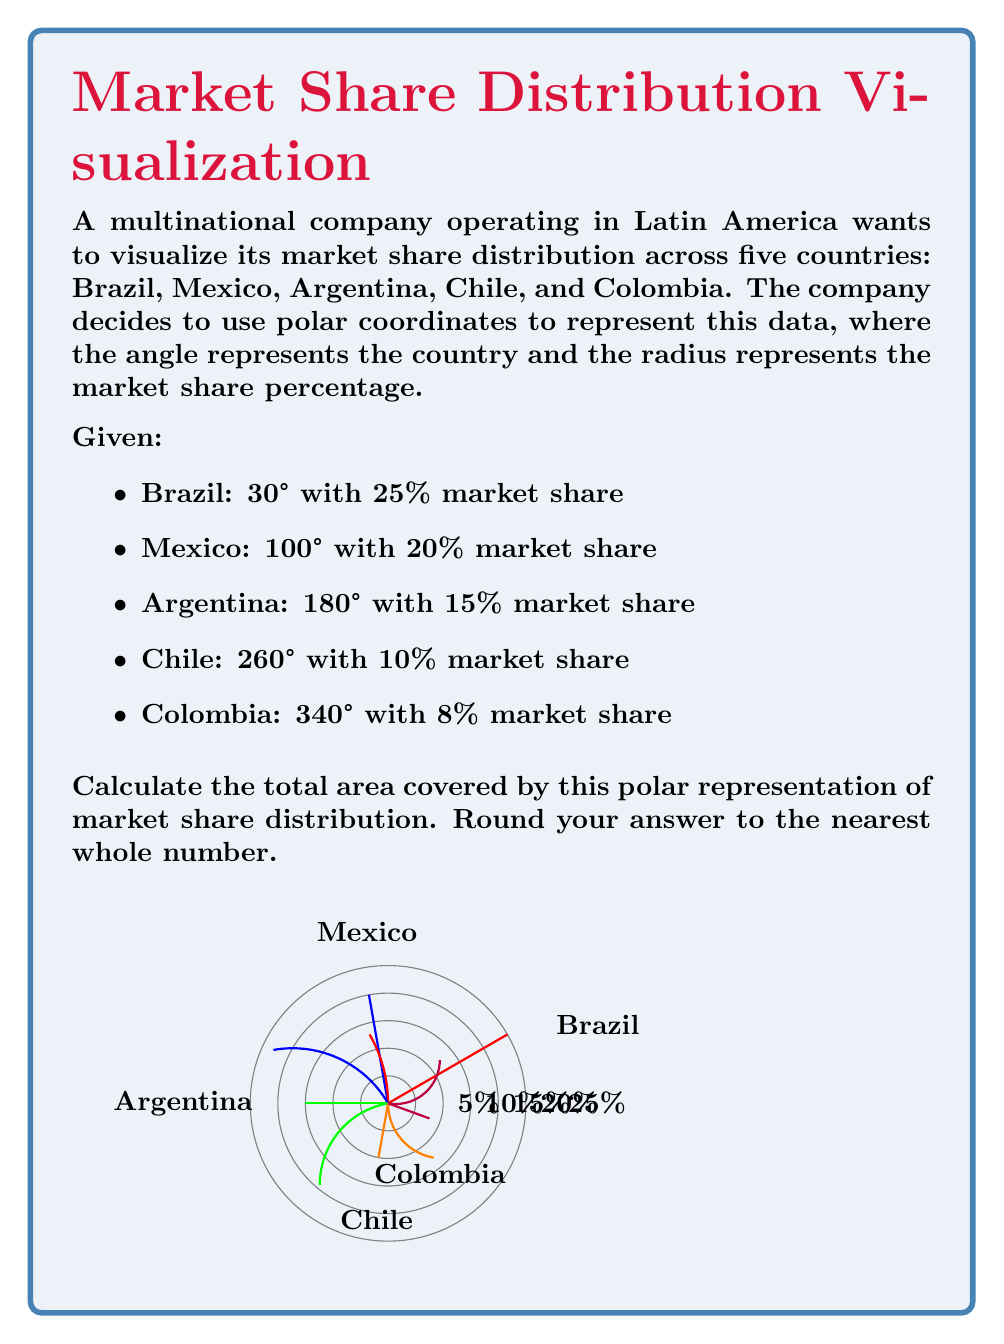Can you solve this math problem? To calculate the total area covered by this polar representation, we need to use the formula for the area of a sector in polar coordinates and sum the areas for all countries.

The formula for the area of a sector in polar coordinates is:

$$ A = \frac{1}{2} r^2 \theta $$

Where $r$ is the radius (market share percentage) and $\theta$ is the central angle in radians.

Step 1: Convert angles to radians and calculate areas for each country.

Brazil:
$\theta = 30° = \frac{30\pi}{180} \approx 0.5236$ radians
$A_1 = \frac{1}{2} (0.25)^2 (0.5236) \approx 0.0164$

Mexico:
$\theta = 70° = \frac{70\pi}{180} \approx 1.2217$ radians
$A_2 = \frac{1}{2} (0.20)^2 (1.2217) \approx 0.0244$

Argentina:
$\theta = 80° = \frac{80\pi}{180} \approx 1.3963$ radians
$A_3 = \frac{1}{2} (0.15)^2 (1.3963) \approx 0.0157$

Chile:
$\theta = 80° = \frac{80\pi}{180} \approx 1.3963$ radians
$A_4 = \frac{1}{2} (0.10)^2 (1.3963) \approx 0.0070$

Colombia:
$\theta = 80° = \frac{80\pi}{180} \approx 1.3963$ radians
$A_5 = \frac{1}{2} (0.08)^2 (1.3963) \approx 0.0045$

Step 2: Sum all areas.

Total Area = $A_1 + A_2 + A_3 + A_4 + A_5$
$= 0.0164 + 0.0244 + 0.0157 + 0.0070 + 0.0045$
$= 0.0680$

Step 3: Round to the nearest whole number.

$0.0680 \times 100 \approx 7$

Therefore, the total area covered by this polar representation of market share distribution is approximately 7 square units.
Answer: 7 square units 